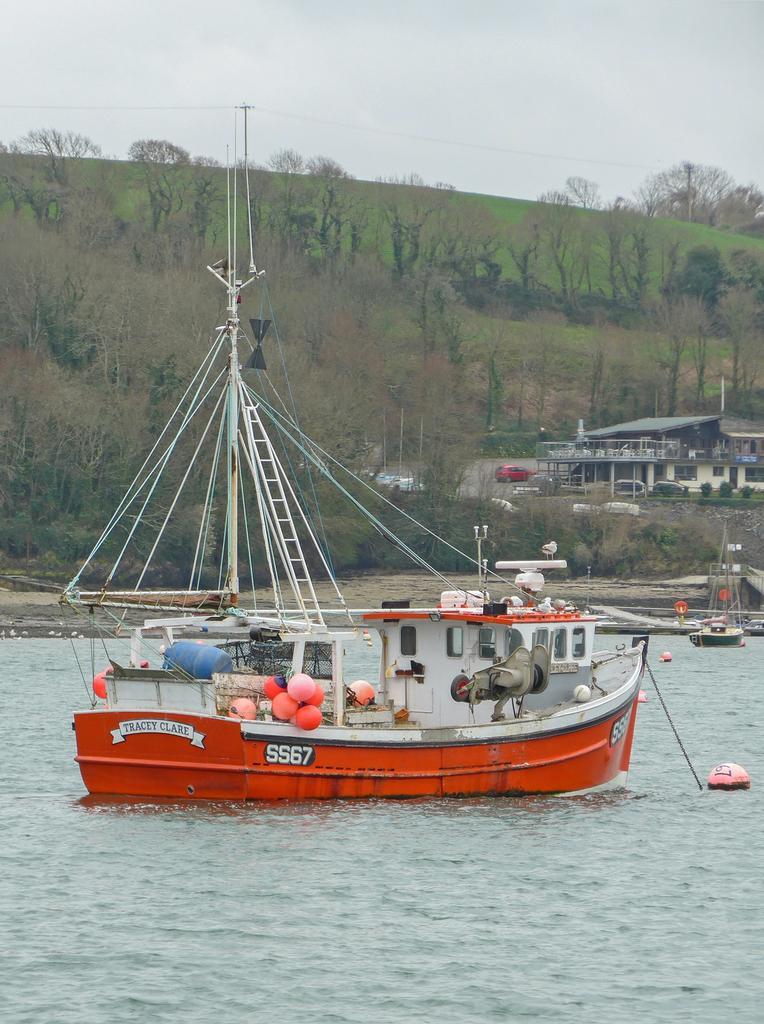Can you describe this image briefly? In this image I can see few boats,poles,water,trees,houses and vehicles. The sky is in white and blue color. 